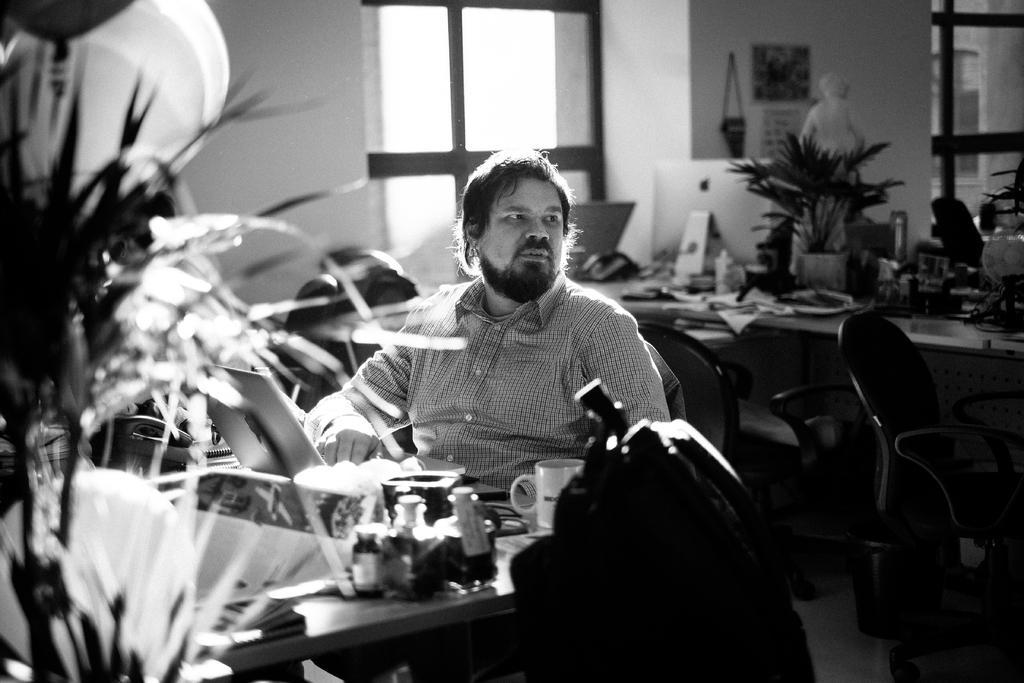Describe this image in one or two sentences. In this image i can a see a person sitting on the chair on the middle and back side of him there is a window and there is a wall and right side i can see a table ,on the table i can see a objects kept on the table. And there is a flower pot on the table and there are some chairs kept on the right side. 